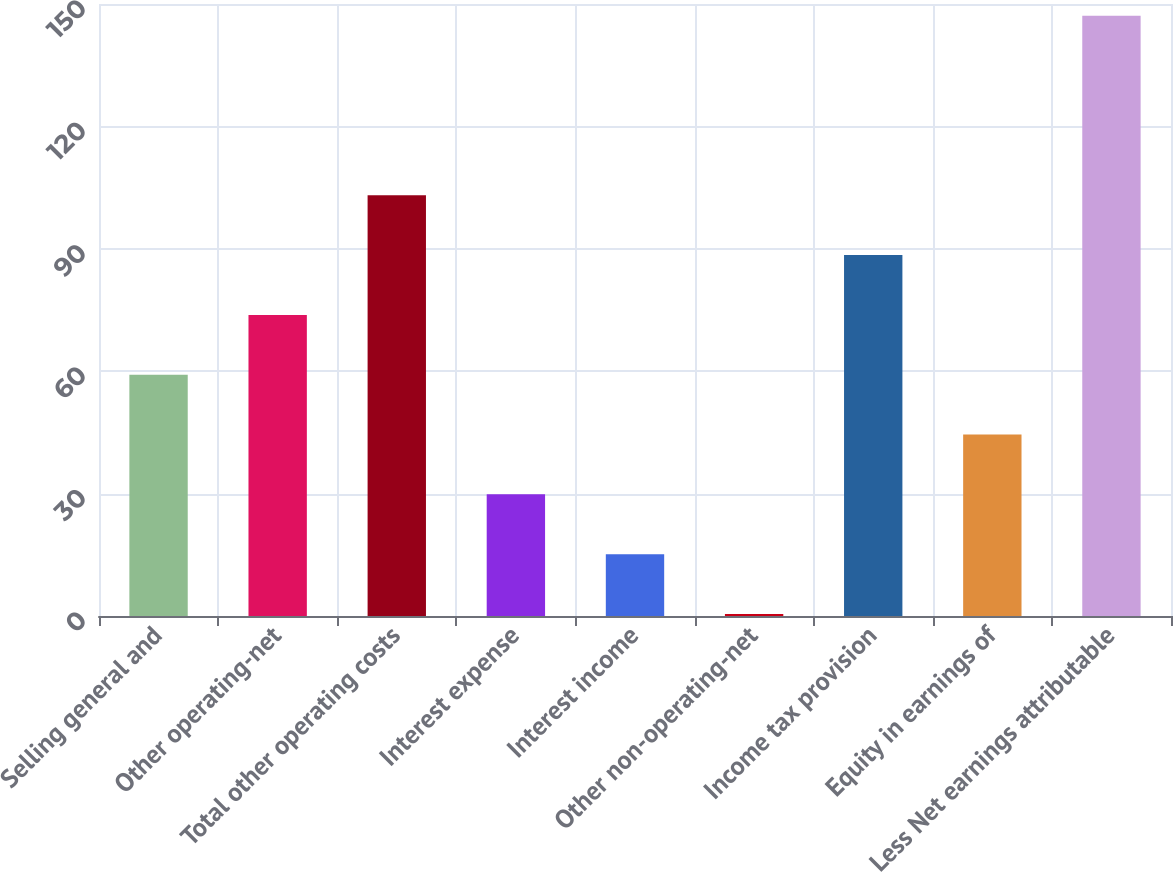<chart> <loc_0><loc_0><loc_500><loc_500><bar_chart><fcel>Selling general and<fcel>Other operating-net<fcel>Total other operating costs<fcel>Interest expense<fcel>Interest income<fcel>Other non-operating-net<fcel>Income tax provision<fcel>Equity in earnings of<fcel>Less Net earnings attributable<nl><fcel>59.14<fcel>73.8<fcel>103.12<fcel>29.82<fcel>15.16<fcel>0.5<fcel>88.46<fcel>44.48<fcel>147.1<nl></chart> 